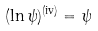<formula> <loc_0><loc_0><loc_500><loc_500>( \ln \psi ) ^ { ( \text {iv} ) } = \psi</formula> 